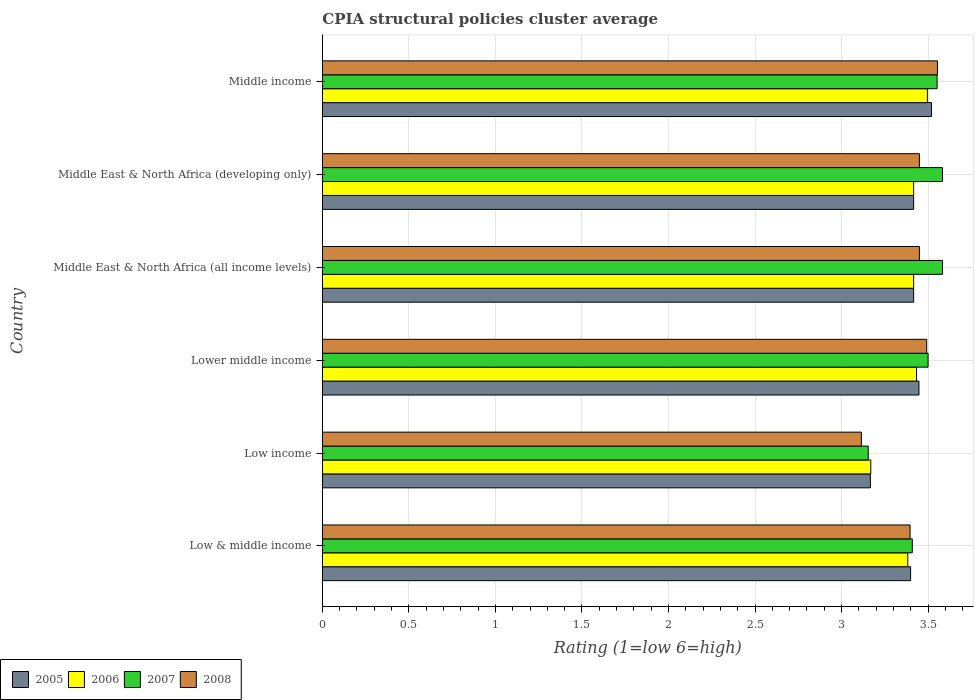How many different coloured bars are there?
Give a very brief answer. 4. How many groups of bars are there?
Offer a very short reply. 6. How many bars are there on the 6th tick from the top?
Offer a terse response. 4. What is the label of the 2nd group of bars from the top?
Offer a very short reply. Middle East & North Africa (developing only). What is the CPIA rating in 2005 in Low & middle income?
Provide a short and direct response. 3.4. Across all countries, what is the maximum CPIA rating in 2007?
Your answer should be compact. 3.58. Across all countries, what is the minimum CPIA rating in 2005?
Provide a succinct answer. 3.17. What is the total CPIA rating in 2006 in the graph?
Give a very brief answer. 20.31. What is the difference between the CPIA rating in 2006 in Low income and that in Middle income?
Keep it short and to the point. -0.33. What is the difference between the CPIA rating in 2005 in Lower middle income and the CPIA rating in 2006 in Low & middle income?
Provide a short and direct response. 0.06. What is the average CPIA rating in 2005 per country?
Your answer should be very brief. 3.39. What is the difference between the CPIA rating in 2006 and CPIA rating in 2007 in Lower middle income?
Provide a succinct answer. -0.07. In how many countries, is the CPIA rating in 2008 greater than 2.1 ?
Your answer should be very brief. 6. What is the ratio of the CPIA rating in 2008 in Low & middle income to that in Low income?
Keep it short and to the point. 1.09. Is the CPIA rating in 2006 in Low income less than that in Middle East & North Africa (developing only)?
Ensure brevity in your answer.  Yes. Is the difference between the CPIA rating in 2006 in Low & middle income and Lower middle income greater than the difference between the CPIA rating in 2007 in Low & middle income and Lower middle income?
Offer a terse response. Yes. What is the difference between the highest and the second highest CPIA rating in 2005?
Keep it short and to the point. 0.07. What is the difference between the highest and the lowest CPIA rating in 2005?
Your answer should be compact. 0.35. Is it the case that in every country, the sum of the CPIA rating in 2005 and CPIA rating in 2006 is greater than the sum of CPIA rating in 2007 and CPIA rating in 2008?
Ensure brevity in your answer.  No. What does the 2nd bar from the bottom in Low & middle income represents?
Your answer should be very brief. 2006. Is it the case that in every country, the sum of the CPIA rating in 2007 and CPIA rating in 2006 is greater than the CPIA rating in 2005?
Give a very brief answer. Yes. How many countries are there in the graph?
Offer a very short reply. 6. Does the graph contain any zero values?
Make the answer very short. No. What is the title of the graph?
Your answer should be compact. CPIA structural policies cluster average. Does "1992" appear as one of the legend labels in the graph?
Make the answer very short. No. What is the label or title of the Y-axis?
Your response must be concise. Country. What is the Rating (1=low 6=high) of 2005 in Low & middle income?
Provide a short and direct response. 3.4. What is the Rating (1=low 6=high) in 2006 in Low & middle income?
Offer a terse response. 3.38. What is the Rating (1=low 6=high) in 2007 in Low & middle income?
Your answer should be very brief. 3.41. What is the Rating (1=low 6=high) of 2008 in Low & middle income?
Offer a terse response. 3.4. What is the Rating (1=low 6=high) of 2005 in Low income?
Your response must be concise. 3.17. What is the Rating (1=low 6=high) in 2006 in Low income?
Your answer should be compact. 3.17. What is the Rating (1=low 6=high) in 2007 in Low income?
Your answer should be very brief. 3.15. What is the Rating (1=low 6=high) of 2008 in Low income?
Your response must be concise. 3.11. What is the Rating (1=low 6=high) of 2005 in Lower middle income?
Give a very brief answer. 3.45. What is the Rating (1=low 6=high) in 2006 in Lower middle income?
Your answer should be compact. 3.43. What is the Rating (1=low 6=high) of 2007 in Lower middle income?
Offer a terse response. 3.5. What is the Rating (1=low 6=high) in 2008 in Lower middle income?
Your response must be concise. 3.49. What is the Rating (1=low 6=high) of 2005 in Middle East & North Africa (all income levels)?
Your answer should be compact. 3.42. What is the Rating (1=low 6=high) in 2006 in Middle East & North Africa (all income levels)?
Provide a succinct answer. 3.42. What is the Rating (1=low 6=high) of 2007 in Middle East & North Africa (all income levels)?
Give a very brief answer. 3.58. What is the Rating (1=low 6=high) of 2008 in Middle East & North Africa (all income levels)?
Make the answer very short. 3.45. What is the Rating (1=low 6=high) of 2005 in Middle East & North Africa (developing only)?
Give a very brief answer. 3.42. What is the Rating (1=low 6=high) in 2006 in Middle East & North Africa (developing only)?
Provide a short and direct response. 3.42. What is the Rating (1=low 6=high) in 2007 in Middle East & North Africa (developing only)?
Offer a very short reply. 3.58. What is the Rating (1=low 6=high) of 2008 in Middle East & North Africa (developing only)?
Ensure brevity in your answer.  3.45. What is the Rating (1=low 6=high) of 2005 in Middle income?
Ensure brevity in your answer.  3.52. What is the Rating (1=low 6=high) in 2006 in Middle income?
Make the answer very short. 3.5. What is the Rating (1=low 6=high) in 2007 in Middle income?
Offer a very short reply. 3.55. What is the Rating (1=low 6=high) in 2008 in Middle income?
Provide a short and direct response. 3.55. Across all countries, what is the maximum Rating (1=low 6=high) in 2005?
Your answer should be very brief. 3.52. Across all countries, what is the maximum Rating (1=low 6=high) in 2006?
Offer a terse response. 3.5. Across all countries, what is the maximum Rating (1=low 6=high) of 2007?
Keep it short and to the point. 3.58. Across all countries, what is the maximum Rating (1=low 6=high) of 2008?
Provide a short and direct response. 3.55. Across all countries, what is the minimum Rating (1=low 6=high) in 2005?
Keep it short and to the point. 3.17. Across all countries, what is the minimum Rating (1=low 6=high) in 2006?
Provide a short and direct response. 3.17. Across all countries, what is the minimum Rating (1=low 6=high) of 2007?
Ensure brevity in your answer.  3.15. Across all countries, what is the minimum Rating (1=low 6=high) in 2008?
Ensure brevity in your answer.  3.11. What is the total Rating (1=low 6=high) of 2005 in the graph?
Your answer should be very brief. 20.37. What is the total Rating (1=low 6=high) in 2006 in the graph?
Offer a very short reply. 20.31. What is the total Rating (1=low 6=high) in 2007 in the graph?
Provide a succinct answer. 20.78. What is the total Rating (1=low 6=high) of 2008 in the graph?
Make the answer very short. 20.46. What is the difference between the Rating (1=low 6=high) in 2005 in Low & middle income and that in Low income?
Provide a short and direct response. 0.23. What is the difference between the Rating (1=low 6=high) of 2006 in Low & middle income and that in Low income?
Provide a short and direct response. 0.21. What is the difference between the Rating (1=low 6=high) of 2007 in Low & middle income and that in Low income?
Provide a succinct answer. 0.25. What is the difference between the Rating (1=low 6=high) of 2008 in Low & middle income and that in Low income?
Your answer should be very brief. 0.28. What is the difference between the Rating (1=low 6=high) in 2005 in Low & middle income and that in Lower middle income?
Your response must be concise. -0.05. What is the difference between the Rating (1=low 6=high) in 2006 in Low & middle income and that in Lower middle income?
Ensure brevity in your answer.  -0.05. What is the difference between the Rating (1=low 6=high) in 2007 in Low & middle income and that in Lower middle income?
Give a very brief answer. -0.09. What is the difference between the Rating (1=low 6=high) of 2008 in Low & middle income and that in Lower middle income?
Make the answer very short. -0.1. What is the difference between the Rating (1=low 6=high) in 2005 in Low & middle income and that in Middle East & North Africa (all income levels)?
Make the answer very short. -0.02. What is the difference between the Rating (1=low 6=high) in 2006 in Low & middle income and that in Middle East & North Africa (all income levels)?
Provide a succinct answer. -0.03. What is the difference between the Rating (1=low 6=high) in 2007 in Low & middle income and that in Middle East & North Africa (all income levels)?
Provide a succinct answer. -0.17. What is the difference between the Rating (1=low 6=high) of 2008 in Low & middle income and that in Middle East & North Africa (all income levels)?
Give a very brief answer. -0.05. What is the difference between the Rating (1=low 6=high) of 2005 in Low & middle income and that in Middle East & North Africa (developing only)?
Keep it short and to the point. -0.02. What is the difference between the Rating (1=low 6=high) of 2006 in Low & middle income and that in Middle East & North Africa (developing only)?
Ensure brevity in your answer.  -0.03. What is the difference between the Rating (1=low 6=high) of 2007 in Low & middle income and that in Middle East & North Africa (developing only)?
Your response must be concise. -0.17. What is the difference between the Rating (1=low 6=high) in 2008 in Low & middle income and that in Middle East & North Africa (developing only)?
Your response must be concise. -0.05. What is the difference between the Rating (1=low 6=high) of 2005 in Low & middle income and that in Middle income?
Make the answer very short. -0.12. What is the difference between the Rating (1=low 6=high) in 2006 in Low & middle income and that in Middle income?
Your response must be concise. -0.11. What is the difference between the Rating (1=low 6=high) in 2007 in Low & middle income and that in Middle income?
Ensure brevity in your answer.  -0.14. What is the difference between the Rating (1=low 6=high) in 2008 in Low & middle income and that in Middle income?
Offer a very short reply. -0.16. What is the difference between the Rating (1=low 6=high) in 2005 in Low income and that in Lower middle income?
Provide a short and direct response. -0.28. What is the difference between the Rating (1=low 6=high) of 2006 in Low income and that in Lower middle income?
Your response must be concise. -0.26. What is the difference between the Rating (1=low 6=high) of 2007 in Low income and that in Lower middle income?
Offer a very short reply. -0.35. What is the difference between the Rating (1=low 6=high) of 2008 in Low income and that in Lower middle income?
Make the answer very short. -0.38. What is the difference between the Rating (1=low 6=high) in 2006 in Low income and that in Middle East & North Africa (all income levels)?
Provide a short and direct response. -0.25. What is the difference between the Rating (1=low 6=high) in 2007 in Low income and that in Middle East & North Africa (all income levels)?
Give a very brief answer. -0.43. What is the difference between the Rating (1=low 6=high) of 2008 in Low income and that in Middle East & North Africa (all income levels)?
Provide a succinct answer. -0.34. What is the difference between the Rating (1=low 6=high) of 2006 in Low income and that in Middle East & North Africa (developing only)?
Your response must be concise. -0.25. What is the difference between the Rating (1=low 6=high) of 2007 in Low income and that in Middle East & North Africa (developing only)?
Ensure brevity in your answer.  -0.43. What is the difference between the Rating (1=low 6=high) in 2008 in Low income and that in Middle East & North Africa (developing only)?
Give a very brief answer. -0.34. What is the difference between the Rating (1=low 6=high) of 2005 in Low income and that in Middle income?
Your response must be concise. -0.35. What is the difference between the Rating (1=low 6=high) of 2006 in Low income and that in Middle income?
Provide a succinct answer. -0.33. What is the difference between the Rating (1=low 6=high) of 2007 in Low income and that in Middle income?
Provide a succinct answer. -0.4. What is the difference between the Rating (1=low 6=high) in 2008 in Low income and that in Middle income?
Your response must be concise. -0.44. What is the difference between the Rating (1=low 6=high) of 2005 in Lower middle income and that in Middle East & North Africa (all income levels)?
Offer a very short reply. 0.03. What is the difference between the Rating (1=low 6=high) of 2006 in Lower middle income and that in Middle East & North Africa (all income levels)?
Ensure brevity in your answer.  0.02. What is the difference between the Rating (1=low 6=high) of 2007 in Lower middle income and that in Middle East & North Africa (all income levels)?
Your response must be concise. -0.08. What is the difference between the Rating (1=low 6=high) of 2008 in Lower middle income and that in Middle East & North Africa (all income levels)?
Offer a very short reply. 0.04. What is the difference between the Rating (1=low 6=high) in 2005 in Lower middle income and that in Middle East & North Africa (developing only)?
Your answer should be very brief. 0.03. What is the difference between the Rating (1=low 6=high) of 2006 in Lower middle income and that in Middle East & North Africa (developing only)?
Offer a very short reply. 0.02. What is the difference between the Rating (1=low 6=high) in 2007 in Lower middle income and that in Middle East & North Africa (developing only)?
Provide a succinct answer. -0.08. What is the difference between the Rating (1=low 6=high) of 2008 in Lower middle income and that in Middle East & North Africa (developing only)?
Offer a terse response. 0.04. What is the difference between the Rating (1=low 6=high) in 2005 in Lower middle income and that in Middle income?
Your answer should be compact. -0.07. What is the difference between the Rating (1=low 6=high) in 2006 in Lower middle income and that in Middle income?
Keep it short and to the point. -0.06. What is the difference between the Rating (1=low 6=high) in 2007 in Lower middle income and that in Middle income?
Give a very brief answer. -0.05. What is the difference between the Rating (1=low 6=high) in 2008 in Lower middle income and that in Middle income?
Your answer should be compact. -0.06. What is the difference between the Rating (1=low 6=high) in 2008 in Middle East & North Africa (all income levels) and that in Middle East & North Africa (developing only)?
Make the answer very short. 0. What is the difference between the Rating (1=low 6=high) of 2005 in Middle East & North Africa (all income levels) and that in Middle income?
Offer a very short reply. -0.1. What is the difference between the Rating (1=low 6=high) in 2006 in Middle East & North Africa (all income levels) and that in Middle income?
Your response must be concise. -0.08. What is the difference between the Rating (1=low 6=high) in 2007 in Middle East & North Africa (all income levels) and that in Middle income?
Provide a short and direct response. 0.03. What is the difference between the Rating (1=low 6=high) of 2008 in Middle East & North Africa (all income levels) and that in Middle income?
Your answer should be very brief. -0.1. What is the difference between the Rating (1=low 6=high) of 2005 in Middle East & North Africa (developing only) and that in Middle income?
Offer a terse response. -0.1. What is the difference between the Rating (1=low 6=high) of 2006 in Middle East & North Africa (developing only) and that in Middle income?
Keep it short and to the point. -0.08. What is the difference between the Rating (1=low 6=high) of 2007 in Middle East & North Africa (developing only) and that in Middle income?
Your response must be concise. 0.03. What is the difference between the Rating (1=low 6=high) in 2008 in Middle East & North Africa (developing only) and that in Middle income?
Offer a very short reply. -0.1. What is the difference between the Rating (1=low 6=high) in 2005 in Low & middle income and the Rating (1=low 6=high) in 2006 in Low income?
Your answer should be compact. 0.23. What is the difference between the Rating (1=low 6=high) of 2005 in Low & middle income and the Rating (1=low 6=high) of 2007 in Low income?
Make the answer very short. 0.24. What is the difference between the Rating (1=low 6=high) in 2005 in Low & middle income and the Rating (1=low 6=high) in 2008 in Low income?
Your answer should be very brief. 0.28. What is the difference between the Rating (1=low 6=high) of 2006 in Low & middle income and the Rating (1=low 6=high) of 2007 in Low income?
Offer a very short reply. 0.23. What is the difference between the Rating (1=low 6=high) of 2006 in Low & middle income and the Rating (1=low 6=high) of 2008 in Low income?
Offer a terse response. 0.27. What is the difference between the Rating (1=low 6=high) in 2007 in Low & middle income and the Rating (1=low 6=high) in 2008 in Low income?
Provide a succinct answer. 0.29. What is the difference between the Rating (1=low 6=high) of 2005 in Low & middle income and the Rating (1=low 6=high) of 2006 in Lower middle income?
Provide a short and direct response. -0.03. What is the difference between the Rating (1=low 6=high) of 2005 in Low & middle income and the Rating (1=low 6=high) of 2007 in Lower middle income?
Your response must be concise. -0.1. What is the difference between the Rating (1=low 6=high) in 2005 in Low & middle income and the Rating (1=low 6=high) in 2008 in Lower middle income?
Ensure brevity in your answer.  -0.09. What is the difference between the Rating (1=low 6=high) in 2006 in Low & middle income and the Rating (1=low 6=high) in 2007 in Lower middle income?
Provide a short and direct response. -0.12. What is the difference between the Rating (1=low 6=high) in 2006 in Low & middle income and the Rating (1=low 6=high) in 2008 in Lower middle income?
Offer a very short reply. -0.11. What is the difference between the Rating (1=low 6=high) in 2007 in Low & middle income and the Rating (1=low 6=high) in 2008 in Lower middle income?
Keep it short and to the point. -0.08. What is the difference between the Rating (1=low 6=high) in 2005 in Low & middle income and the Rating (1=low 6=high) in 2006 in Middle East & North Africa (all income levels)?
Provide a short and direct response. -0.02. What is the difference between the Rating (1=low 6=high) in 2005 in Low & middle income and the Rating (1=low 6=high) in 2007 in Middle East & North Africa (all income levels)?
Keep it short and to the point. -0.18. What is the difference between the Rating (1=low 6=high) of 2005 in Low & middle income and the Rating (1=low 6=high) of 2008 in Middle East & North Africa (all income levels)?
Provide a short and direct response. -0.05. What is the difference between the Rating (1=low 6=high) of 2006 in Low & middle income and the Rating (1=low 6=high) of 2007 in Middle East & North Africa (all income levels)?
Provide a succinct answer. -0.2. What is the difference between the Rating (1=low 6=high) in 2006 in Low & middle income and the Rating (1=low 6=high) in 2008 in Middle East & North Africa (all income levels)?
Provide a short and direct response. -0.07. What is the difference between the Rating (1=low 6=high) in 2007 in Low & middle income and the Rating (1=low 6=high) in 2008 in Middle East & North Africa (all income levels)?
Offer a terse response. -0.04. What is the difference between the Rating (1=low 6=high) in 2005 in Low & middle income and the Rating (1=low 6=high) in 2006 in Middle East & North Africa (developing only)?
Keep it short and to the point. -0.02. What is the difference between the Rating (1=low 6=high) in 2005 in Low & middle income and the Rating (1=low 6=high) in 2007 in Middle East & North Africa (developing only)?
Give a very brief answer. -0.18. What is the difference between the Rating (1=low 6=high) of 2005 in Low & middle income and the Rating (1=low 6=high) of 2008 in Middle East & North Africa (developing only)?
Keep it short and to the point. -0.05. What is the difference between the Rating (1=low 6=high) in 2006 in Low & middle income and the Rating (1=low 6=high) in 2007 in Middle East & North Africa (developing only)?
Give a very brief answer. -0.2. What is the difference between the Rating (1=low 6=high) in 2006 in Low & middle income and the Rating (1=low 6=high) in 2008 in Middle East & North Africa (developing only)?
Ensure brevity in your answer.  -0.07. What is the difference between the Rating (1=low 6=high) of 2007 in Low & middle income and the Rating (1=low 6=high) of 2008 in Middle East & North Africa (developing only)?
Your answer should be very brief. -0.04. What is the difference between the Rating (1=low 6=high) of 2005 in Low & middle income and the Rating (1=low 6=high) of 2006 in Middle income?
Offer a very short reply. -0.1. What is the difference between the Rating (1=low 6=high) of 2005 in Low & middle income and the Rating (1=low 6=high) of 2007 in Middle income?
Make the answer very short. -0.15. What is the difference between the Rating (1=low 6=high) of 2005 in Low & middle income and the Rating (1=low 6=high) of 2008 in Middle income?
Make the answer very short. -0.15. What is the difference between the Rating (1=low 6=high) in 2006 in Low & middle income and the Rating (1=low 6=high) in 2007 in Middle income?
Provide a short and direct response. -0.17. What is the difference between the Rating (1=low 6=high) in 2006 in Low & middle income and the Rating (1=low 6=high) in 2008 in Middle income?
Provide a succinct answer. -0.17. What is the difference between the Rating (1=low 6=high) in 2007 in Low & middle income and the Rating (1=low 6=high) in 2008 in Middle income?
Provide a succinct answer. -0.15. What is the difference between the Rating (1=low 6=high) of 2005 in Low income and the Rating (1=low 6=high) of 2006 in Lower middle income?
Provide a succinct answer. -0.27. What is the difference between the Rating (1=low 6=high) of 2005 in Low income and the Rating (1=low 6=high) of 2007 in Lower middle income?
Offer a terse response. -0.33. What is the difference between the Rating (1=low 6=high) in 2005 in Low income and the Rating (1=low 6=high) in 2008 in Lower middle income?
Your answer should be compact. -0.33. What is the difference between the Rating (1=low 6=high) of 2006 in Low income and the Rating (1=low 6=high) of 2007 in Lower middle income?
Ensure brevity in your answer.  -0.33. What is the difference between the Rating (1=low 6=high) in 2006 in Low income and the Rating (1=low 6=high) in 2008 in Lower middle income?
Offer a terse response. -0.32. What is the difference between the Rating (1=low 6=high) in 2007 in Low income and the Rating (1=low 6=high) in 2008 in Lower middle income?
Keep it short and to the point. -0.34. What is the difference between the Rating (1=low 6=high) of 2005 in Low income and the Rating (1=low 6=high) of 2007 in Middle East & North Africa (all income levels)?
Your answer should be very brief. -0.42. What is the difference between the Rating (1=low 6=high) of 2005 in Low income and the Rating (1=low 6=high) of 2008 in Middle East & North Africa (all income levels)?
Provide a short and direct response. -0.28. What is the difference between the Rating (1=low 6=high) of 2006 in Low income and the Rating (1=low 6=high) of 2007 in Middle East & North Africa (all income levels)?
Keep it short and to the point. -0.41. What is the difference between the Rating (1=low 6=high) in 2006 in Low income and the Rating (1=low 6=high) in 2008 in Middle East & North Africa (all income levels)?
Provide a short and direct response. -0.28. What is the difference between the Rating (1=low 6=high) in 2007 in Low income and the Rating (1=low 6=high) in 2008 in Middle East & North Africa (all income levels)?
Offer a very short reply. -0.3. What is the difference between the Rating (1=low 6=high) of 2005 in Low income and the Rating (1=low 6=high) of 2007 in Middle East & North Africa (developing only)?
Your answer should be very brief. -0.42. What is the difference between the Rating (1=low 6=high) in 2005 in Low income and the Rating (1=low 6=high) in 2008 in Middle East & North Africa (developing only)?
Give a very brief answer. -0.28. What is the difference between the Rating (1=low 6=high) of 2006 in Low income and the Rating (1=low 6=high) of 2007 in Middle East & North Africa (developing only)?
Offer a very short reply. -0.41. What is the difference between the Rating (1=low 6=high) of 2006 in Low income and the Rating (1=low 6=high) of 2008 in Middle East & North Africa (developing only)?
Give a very brief answer. -0.28. What is the difference between the Rating (1=low 6=high) in 2007 in Low income and the Rating (1=low 6=high) in 2008 in Middle East & North Africa (developing only)?
Provide a short and direct response. -0.3. What is the difference between the Rating (1=low 6=high) of 2005 in Low income and the Rating (1=low 6=high) of 2006 in Middle income?
Provide a short and direct response. -0.33. What is the difference between the Rating (1=low 6=high) of 2005 in Low income and the Rating (1=low 6=high) of 2007 in Middle income?
Provide a short and direct response. -0.39. What is the difference between the Rating (1=low 6=high) in 2005 in Low income and the Rating (1=low 6=high) in 2008 in Middle income?
Ensure brevity in your answer.  -0.39. What is the difference between the Rating (1=low 6=high) of 2006 in Low income and the Rating (1=low 6=high) of 2007 in Middle income?
Offer a very short reply. -0.38. What is the difference between the Rating (1=low 6=high) in 2006 in Low income and the Rating (1=low 6=high) in 2008 in Middle income?
Provide a short and direct response. -0.39. What is the difference between the Rating (1=low 6=high) in 2007 in Low income and the Rating (1=low 6=high) in 2008 in Middle income?
Give a very brief answer. -0.4. What is the difference between the Rating (1=low 6=high) in 2005 in Lower middle income and the Rating (1=low 6=high) in 2006 in Middle East & North Africa (all income levels)?
Make the answer very short. 0.03. What is the difference between the Rating (1=low 6=high) of 2005 in Lower middle income and the Rating (1=low 6=high) of 2007 in Middle East & North Africa (all income levels)?
Provide a short and direct response. -0.14. What is the difference between the Rating (1=low 6=high) of 2005 in Lower middle income and the Rating (1=low 6=high) of 2008 in Middle East & North Africa (all income levels)?
Offer a terse response. -0. What is the difference between the Rating (1=low 6=high) in 2006 in Lower middle income and the Rating (1=low 6=high) in 2008 in Middle East & North Africa (all income levels)?
Offer a terse response. -0.02. What is the difference between the Rating (1=low 6=high) in 2007 in Lower middle income and the Rating (1=low 6=high) in 2008 in Middle East & North Africa (all income levels)?
Keep it short and to the point. 0.05. What is the difference between the Rating (1=low 6=high) of 2005 in Lower middle income and the Rating (1=low 6=high) of 2006 in Middle East & North Africa (developing only)?
Your response must be concise. 0.03. What is the difference between the Rating (1=low 6=high) of 2005 in Lower middle income and the Rating (1=low 6=high) of 2007 in Middle East & North Africa (developing only)?
Keep it short and to the point. -0.14. What is the difference between the Rating (1=low 6=high) of 2005 in Lower middle income and the Rating (1=low 6=high) of 2008 in Middle East & North Africa (developing only)?
Offer a very short reply. -0. What is the difference between the Rating (1=low 6=high) of 2006 in Lower middle income and the Rating (1=low 6=high) of 2008 in Middle East & North Africa (developing only)?
Provide a short and direct response. -0.02. What is the difference between the Rating (1=low 6=high) of 2005 in Lower middle income and the Rating (1=low 6=high) of 2006 in Middle income?
Offer a terse response. -0.05. What is the difference between the Rating (1=low 6=high) in 2005 in Lower middle income and the Rating (1=low 6=high) in 2007 in Middle income?
Your answer should be very brief. -0.1. What is the difference between the Rating (1=low 6=high) in 2005 in Lower middle income and the Rating (1=low 6=high) in 2008 in Middle income?
Make the answer very short. -0.11. What is the difference between the Rating (1=low 6=high) of 2006 in Lower middle income and the Rating (1=low 6=high) of 2007 in Middle income?
Keep it short and to the point. -0.12. What is the difference between the Rating (1=low 6=high) of 2006 in Lower middle income and the Rating (1=low 6=high) of 2008 in Middle income?
Offer a very short reply. -0.12. What is the difference between the Rating (1=low 6=high) of 2007 in Lower middle income and the Rating (1=low 6=high) of 2008 in Middle income?
Give a very brief answer. -0.05. What is the difference between the Rating (1=low 6=high) in 2005 in Middle East & North Africa (all income levels) and the Rating (1=low 6=high) in 2008 in Middle East & North Africa (developing only)?
Provide a short and direct response. -0.03. What is the difference between the Rating (1=low 6=high) in 2006 in Middle East & North Africa (all income levels) and the Rating (1=low 6=high) in 2007 in Middle East & North Africa (developing only)?
Give a very brief answer. -0.17. What is the difference between the Rating (1=low 6=high) in 2006 in Middle East & North Africa (all income levels) and the Rating (1=low 6=high) in 2008 in Middle East & North Africa (developing only)?
Provide a short and direct response. -0.03. What is the difference between the Rating (1=low 6=high) of 2007 in Middle East & North Africa (all income levels) and the Rating (1=low 6=high) of 2008 in Middle East & North Africa (developing only)?
Make the answer very short. 0.13. What is the difference between the Rating (1=low 6=high) in 2005 in Middle East & North Africa (all income levels) and the Rating (1=low 6=high) in 2006 in Middle income?
Keep it short and to the point. -0.08. What is the difference between the Rating (1=low 6=high) in 2005 in Middle East & North Africa (all income levels) and the Rating (1=low 6=high) in 2007 in Middle income?
Your answer should be very brief. -0.14. What is the difference between the Rating (1=low 6=high) of 2005 in Middle East & North Africa (all income levels) and the Rating (1=low 6=high) of 2008 in Middle income?
Your answer should be very brief. -0.14. What is the difference between the Rating (1=low 6=high) in 2006 in Middle East & North Africa (all income levels) and the Rating (1=low 6=high) in 2007 in Middle income?
Provide a short and direct response. -0.14. What is the difference between the Rating (1=low 6=high) in 2006 in Middle East & North Africa (all income levels) and the Rating (1=low 6=high) in 2008 in Middle income?
Keep it short and to the point. -0.14. What is the difference between the Rating (1=low 6=high) in 2007 in Middle East & North Africa (all income levels) and the Rating (1=low 6=high) in 2008 in Middle income?
Ensure brevity in your answer.  0.03. What is the difference between the Rating (1=low 6=high) in 2005 in Middle East & North Africa (developing only) and the Rating (1=low 6=high) in 2006 in Middle income?
Make the answer very short. -0.08. What is the difference between the Rating (1=low 6=high) in 2005 in Middle East & North Africa (developing only) and the Rating (1=low 6=high) in 2007 in Middle income?
Your answer should be very brief. -0.14. What is the difference between the Rating (1=low 6=high) in 2005 in Middle East & North Africa (developing only) and the Rating (1=low 6=high) in 2008 in Middle income?
Offer a terse response. -0.14. What is the difference between the Rating (1=low 6=high) in 2006 in Middle East & North Africa (developing only) and the Rating (1=low 6=high) in 2007 in Middle income?
Your answer should be compact. -0.14. What is the difference between the Rating (1=low 6=high) in 2006 in Middle East & North Africa (developing only) and the Rating (1=low 6=high) in 2008 in Middle income?
Your answer should be compact. -0.14. What is the difference between the Rating (1=low 6=high) in 2007 in Middle East & North Africa (developing only) and the Rating (1=low 6=high) in 2008 in Middle income?
Make the answer very short. 0.03. What is the average Rating (1=low 6=high) of 2005 per country?
Your answer should be very brief. 3.39. What is the average Rating (1=low 6=high) of 2006 per country?
Your answer should be compact. 3.39. What is the average Rating (1=low 6=high) of 2007 per country?
Ensure brevity in your answer.  3.46. What is the average Rating (1=low 6=high) of 2008 per country?
Give a very brief answer. 3.41. What is the difference between the Rating (1=low 6=high) in 2005 and Rating (1=low 6=high) in 2006 in Low & middle income?
Provide a succinct answer. 0.02. What is the difference between the Rating (1=low 6=high) in 2005 and Rating (1=low 6=high) in 2007 in Low & middle income?
Keep it short and to the point. -0.01. What is the difference between the Rating (1=low 6=high) of 2005 and Rating (1=low 6=high) of 2008 in Low & middle income?
Provide a succinct answer. 0. What is the difference between the Rating (1=low 6=high) in 2006 and Rating (1=low 6=high) in 2007 in Low & middle income?
Provide a succinct answer. -0.03. What is the difference between the Rating (1=low 6=high) of 2006 and Rating (1=low 6=high) of 2008 in Low & middle income?
Ensure brevity in your answer.  -0.01. What is the difference between the Rating (1=low 6=high) of 2007 and Rating (1=low 6=high) of 2008 in Low & middle income?
Your response must be concise. 0.01. What is the difference between the Rating (1=low 6=high) of 2005 and Rating (1=low 6=high) of 2006 in Low income?
Your answer should be very brief. -0. What is the difference between the Rating (1=low 6=high) of 2005 and Rating (1=low 6=high) of 2007 in Low income?
Offer a terse response. 0.01. What is the difference between the Rating (1=low 6=high) in 2005 and Rating (1=low 6=high) in 2008 in Low income?
Keep it short and to the point. 0.05. What is the difference between the Rating (1=low 6=high) of 2006 and Rating (1=low 6=high) of 2007 in Low income?
Keep it short and to the point. 0.01. What is the difference between the Rating (1=low 6=high) in 2006 and Rating (1=low 6=high) in 2008 in Low income?
Ensure brevity in your answer.  0.05. What is the difference between the Rating (1=low 6=high) of 2007 and Rating (1=low 6=high) of 2008 in Low income?
Provide a short and direct response. 0.04. What is the difference between the Rating (1=low 6=high) in 2005 and Rating (1=low 6=high) in 2006 in Lower middle income?
Your answer should be compact. 0.01. What is the difference between the Rating (1=low 6=high) of 2005 and Rating (1=low 6=high) of 2007 in Lower middle income?
Make the answer very short. -0.05. What is the difference between the Rating (1=low 6=high) in 2005 and Rating (1=low 6=high) in 2008 in Lower middle income?
Give a very brief answer. -0.04. What is the difference between the Rating (1=low 6=high) in 2006 and Rating (1=low 6=high) in 2007 in Lower middle income?
Give a very brief answer. -0.07. What is the difference between the Rating (1=low 6=high) of 2006 and Rating (1=low 6=high) of 2008 in Lower middle income?
Offer a terse response. -0.06. What is the difference between the Rating (1=low 6=high) in 2007 and Rating (1=low 6=high) in 2008 in Lower middle income?
Your answer should be compact. 0.01. What is the difference between the Rating (1=low 6=high) of 2005 and Rating (1=low 6=high) of 2007 in Middle East & North Africa (all income levels)?
Your response must be concise. -0.17. What is the difference between the Rating (1=low 6=high) in 2005 and Rating (1=low 6=high) in 2008 in Middle East & North Africa (all income levels)?
Offer a terse response. -0.03. What is the difference between the Rating (1=low 6=high) in 2006 and Rating (1=low 6=high) in 2007 in Middle East & North Africa (all income levels)?
Keep it short and to the point. -0.17. What is the difference between the Rating (1=low 6=high) in 2006 and Rating (1=low 6=high) in 2008 in Middle East & North Africa (all income levels)?
Your answer should be compact. -0.03. What is the difference between the Rating (1=low 6=high) of 2007 and Rating (1=low 6=high) of 2008 in Middle East & North Africa (all income levels)?
Ensure brevity in your answer.  0.13. What is the difference between the Rating (1=low 6=high) in 2005 and Rating (1=low 6=high) in 2006 in Middle East & North Africa (developing only)?
Provide a short and direct response. 0. What is the difference between the Rating (1=low 6=high) of 2005 and Rating (1=low 6=high) of 2007 in Middle East & North Africa (developing only)?
Ensure brevity in your answer.  -0.17. What is the difference between the Rating (1=low 6=high) in 2005 and Rating (1=low 6=high) in 2008 in Middle East & North Africa (developing only)?
Keep it short and to the point. -0.03. What is the difference between the Rating (1=low 6=high) in 2006 and Rating (1=low 6=high) in 2007 in Middle East & North Africa (developing only)?
Offer a terse response. -0.17. What is the difference between the Rating (1=low 6=high) in 2006 and Rating (1=low 6=high) in 2008 in Middle East & North Africa (developing only)?
Your answer should be very brief. -0.03. What is the difference between the Rating (1=low 6=high) of 2007 and Rating (1=low 6=high) of 2008 in Middle East & North Africa (developing only)?
Provide a succinct answer. 0.13. What is the difference between the Rating (1=low 6=high) in 2005 and Rating (1=low 6=high) in 2006 in Middle income?
Your response must be concise. 0.02. What is the difference between the Rating (1=low 6=high) in 2005 and Rating (1=low 6=high) in 2007 in Middle income?
Keep it short and to the point. -0.03. What is the difference between the Rating (1=low 6=high) in 2005 and Rating (1=low 6=high) in 2008 in Middle income?
Provide a short and direct response. -0.03. What is the difference between the Rating (1=low 6=high) of 2006 and Rating (1=low 6=high) of 2007 in Middle income?
Keep it short and to the point. -0.06. What is the difference between the Rating (1=low 6=high) in 2006 and Rating (1=low 6=high) in 2008 in Middle income?
Ensure brevity in your answer.  -0.06. What is the difference between the Rating (1=low 6=high) of 2007 and Rating (1=low 6=high) of 2008 in Middle income?
Give a very brief answer. -0. What is the ratio of the Rating (1=low 6=high) of 2005 in Low & middle income to that in Low income?
Your response must be concise. 1.07. What is the ratio of the Rating (1=low 6=high) of 2006 in Low & middle income to that in Low income?
Provide a short and direct response. 1.07. What is the ratio of the Rating (1=low 6=high) in 2007 in Low & middle income to that in Low income?
Offer a terse response. 1.08. What is the ratio of the Rating (1=low 6=high) in 2008 in Low & middle income to that in Low income?
Ensure brevity in your answer.  1.09. What is the ratio of the Rating (1=low 6=high) in 2005 in Low & middle income to that in Lower middle income?
Provide a short and direct response. 0.99. What is the ratio of the Rating (1=low 6=high) in 2006 in Low & middle income to that in Lower middle income?
Make the answer very short. 0.99. What is the ratio of the Rating (1=low 6=high) in 2008 in Low & middle income to that in Lower middle income?
Your answer should be compact. 0.97. What is the ratio of the Rating (1=low 6=high) of 2006 in Low & middle income to that in Middle East & North Africa (all income levels)?
Your answer should be compact. 0.99. What is the ratio of the Rating (1=low 6=high) of 2007 in Low & middle income to that in Middle East & North Africa (all income levels)?
Ensure brevity in your answer.  0.95. What is the ratio of the Rating (1=low 6=high) of 2008 in Low & middle income to that in Middle East & North Africa (all income levels)?
Keep it short and to the point. 0.98. What is the ratio of the Rating (1=low 6=high) in 2005 in Low & middle income to that in Middle East & North Africa (developing only)?
Provide a succinct answer. 0.99. What is the ratio of the Rating (1=low 6=high) in 2006 in Low & middle income to that in Middle East & North Africa (developing only)?
Provide a succinct answer. 0.99. What is the ratio of the Rating (1=low 6=high) in 2007 in Low & middle income to that in Middle East & North Africa (developing only)?
Ensure brevity in your answer.  0.95. What is the ratio of the Rating (1=low 6=high) of 2008 in Low & middle income to that in Middle East & North Africa (developing only)?
Offer a very short reply. 0.98. What is the ratio of the Rating (1=low 6=high) in 2005 in Low & middle income to that in Middle income?
Make the answer very short. 0.97. What is the ratio of the Rating (1=low 6=high) of 2006 in Low & middle income to that in Middle income?
Provide a short and direct response. 0.97. What is the ratio of the Rating (1=low 6=high) of 2007 in Low & middle income to that in Middle income?
Make the answer very short. 0.96. What is the ratio of the Rating (1=low 6=high) of 2008 in Low & middle income to that in Middle income?
Offer a very short reply. 0.96. What is the ratio of the Rating (1=low 6=high) in 2005 in Low income to that in Lower middle income?
Your answer should be compact. 0.92. What is the ratio of the Rating (1=low 6=high) in 2006 in Low income to that in Lower middle income?
Provide a succinct answer. 0.92. What is the ratio of the Rating (1=low 6=high) of 2007 in Low income to that in Lower middle income?
Provide a short and direct response. 0.9. What is the ratio of the Rating (1=low 6=high) in 2008 in Low income to that in Lower middle income?
Provide a short and direct response. 0.89. What is the ratio of the Rating (1=low 6=high) in 2005 in Low income to that in Middle East & North Africa (all income levels)?
Give a very brief answer. 0.93. What is the ratio of the Rating (1=low 6=high) of 2006 in Low income to that in Middle East & North Africa (all income levels)?
Your answer should be compact. 0.93. What is the ratio of the Rating (1=low 6=high) of 2007 in Low income to that in Middle East & North Africa (all income levels)?
Your response must be concise. 0.88. What is the ratio of the Rating (1=low 6=high) of 2008 in Low income to that in Middle East & North Africa (all income levels)?
Keep it short and to the point. 0.9. What is the ratio of the Rating (1=low 6=high) of 2005 in Low income to that in Middle East & North Africa (developing only)?
Offer a very short reply. 0.93. What is the ratio of the Rating (1=low 6=high) of 2006 in Low income to that in Middle East & North Africa (developing only)?
Give a very brief answer. 0.93. What is the ratio of the Rating (1=low 6=high) in 2007 in Low income to that in Middle East & North Africa (developing only)?
Make the answer very short. 0.88. What is the ratio of the Rating (1=low 6=high) of 2008 in Low income to that in Middle East & North Africa (developing only)?
Your response must be concise. 0.9. What is the ratio of the Rating (1=low 6=high) in 2005 in Low income to that in Middle income?
Offer a very short reply. 0.9. What is the ratio of the Rating (1=low 6=high) of 2006 in Low income to that in Middle income?
Provide a succinct answer. 0.91. What is the ratio of the Rating (1=low 6=high) of 2007 in Low income to that in Middle income?
Provide a succinct answer. 0.89. What is the ratio of the Rating (1=low 6=high) of 2008 in Low income to that in Middle income?
Your response must be concise. 0.88. What is the ratio of the Rating (1=low 6=high) of 2005 in Lower middle income to that in Middle East & North Africa (all income levels)?
Keep it short and to the point. 1.01. What is the ratio of the Rating (1=low 6=high) in 2007 in Lower middle income to that in Middle East & North Africa (all income levels)?
Keep it short and to the point. 0.98. What is the ratio of the Rating (1=low 6=high) of 2008 in Lower middle income to that in Middle East & North Africa (all income levels)?
Offer a terse response. 1.01. What is the ratio of the Rating (1=low 6=high) in 2005 in Lower middle income to that in Middle East & North Africa (developing only)?
Your answer should be compact. 1.01. What is the ratio of the Rating (1=low 6=high) in 2006 in Lower middle income to that in Middle East & North Africa (developing only)?
Ensure brevity in your answer.  1. What is the ratio of the Rating (1=low 6=high) of 2007 in Lower middle income to that in Middle East & North Africa (developing only)?
Keep it short and to the point. 0.98. What is the ratio of the Rating (1=low 6=high) in 2008 in Lower middle income to that in Middle East & North Africa (developing only)?
Offer a very short reply. 1.01. What is the ratio of the Rating (1=low 6=high) of 2005 in Lower middle income to that in Middle income?
Ensure brevity in your answer.  0.98. What is the ratio of the Rating (1=low 6=high) of 2006 in Lower middle income to that in Middle income?
Provide a succinct answer. 0.98. What is the ratio of the Rating (1=low 6=high) of 2007 in Lower middle income to that in Middle income?
Your response must be concise. 0.99. What is the ratio of the Rating (1=low 6=high) of 2008 in Lower middle income to that in Middle income?
Your answer should be compact. 0.98. What is the ratio of the Rating (1=low 6=high) in 2006 in Middle East & North Africa (all income levels) to that in Middle East & North Africa (developing only)?
Keep it short and to the point. 1. What is the ratio of the Rating (1=low 6=high) in 2007 in Middle East & North Africa (all income levels) to that in Middle East & North Africa (developing only)?
Your response must be concise. 1. What is the ratio of the Rating (1=low 6=high) in 2005 in Middle East & North Africa (all income levels) to that in Middle income?
Offer a very short reply. 0.97. What is the ratio of the Rating (1=low 6=high) in 2006 in Middle East & North Africa (all income levels) to that in Middle income?
Make the answer very short. 0.98. What is the ratio of the Rating (1=low 6=high) in 2007 in Middle East & North Africa (all income levels) to that in Middle income?
Make the answer very short. 1.01. What is the ratio of the Rating (1=low 6=high) in 2008 in Middle East & North Africa (all income levels) to that in Middle income?
Ensure brevity in your answer.  0.97. What is the ratio of the Rating (1=low 6=high) in 2005 in Middle East & North Africa (developing only) to that in Middle income?
Provide a short and direct response. 0.97. What is the ratio of the Rating (1=low 6=high) of 2006 in Middle East & North Africa (developing only) to that in Middle income?
Your answer should be compact. 0.98. What is the ratio of the Rating (1=low 6=high) in 2007 in Middle East & North Africa (developing only) to that in Middle income?
Keep it short and to the point. 1.01. What is the ratio of the Rating (1=low 6=high) of 2008 in Middle East & North Africa (developing only) to that in Middle income?
Make the answer very short. 0.97. What is the difference between the highest and the second highest Rating (1=low 6=high) in 2005?
Keep it short and to the point. 0.07. What is the difference between the highest and the second highest Rating (1=low 6=high) in 2006?
Provide a succinct answer. 0.06. What is the difference between the highest and the second highest Rating (1=low 6=high) in 2007?
Your answer should be very brief. 0. What is the difference between the highest and the second highest Rating (1=low 6=high) of 2008?
Keep it short and to the point. 0.06. What is the difference between the highest and the lowest Rating (1=low 6=high) in 2005?
Make the answer very short. 0.35. What is the difference between the highest and the lowest Rating (1=low 6=high) of 2006?
Offer a terse response. 0.33. What is the difference between the highest and the lowest Rating (1=low 6=high) in 2007?
Offer a very short reply. 0.43. What is the difference between the highest and the lowest Rating (1=low 6=high) in 2008?
Make the answer very short. 0.44. 